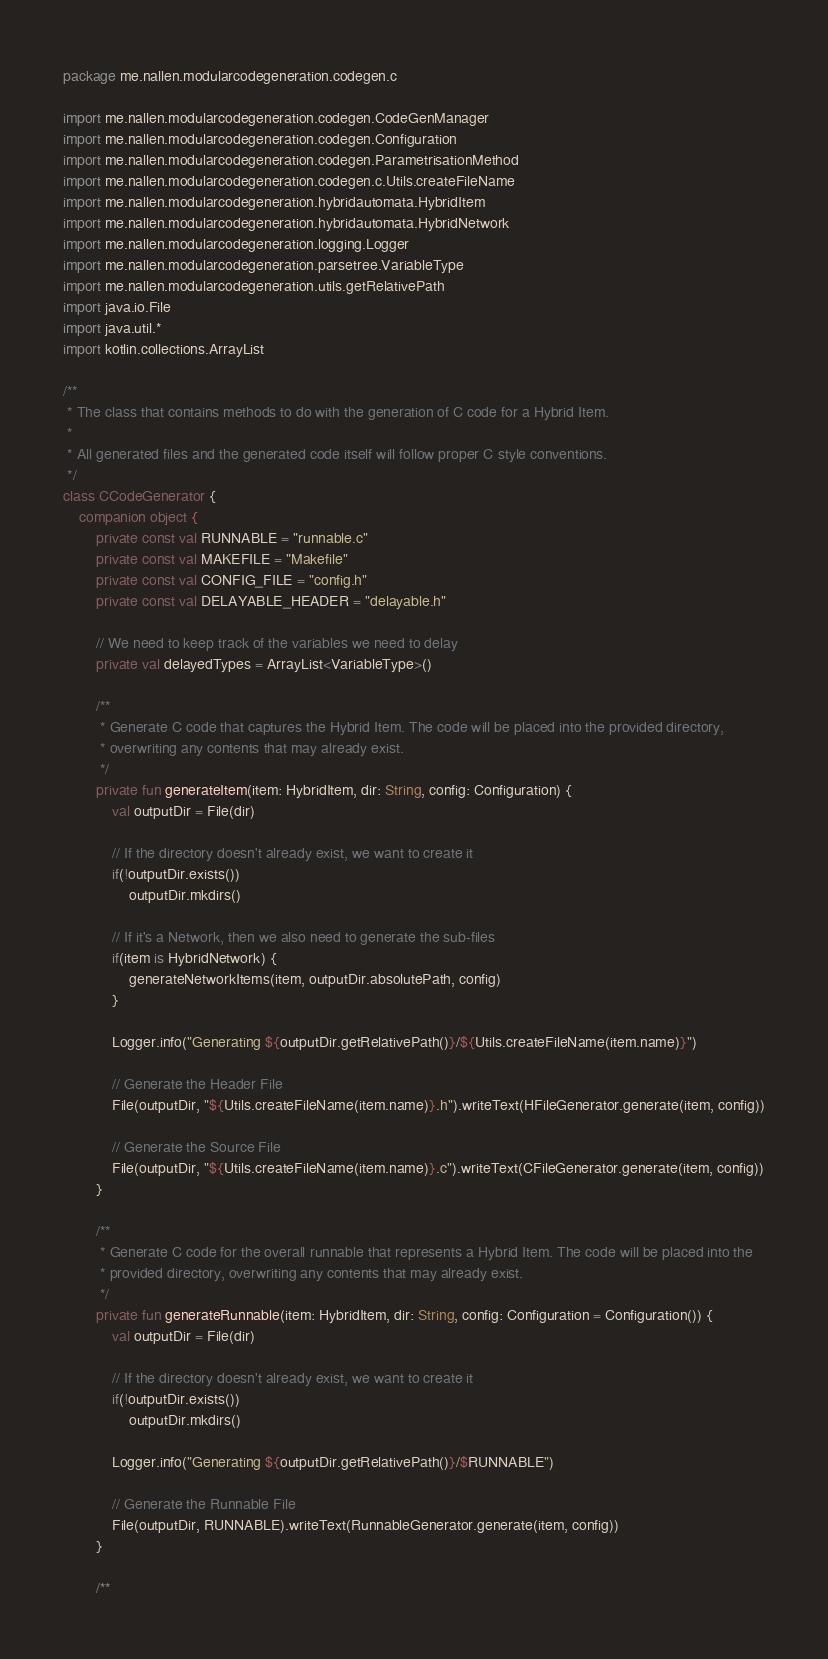Convert code to text. <code><loc_0><loc_0><loc_500><loc_500><_Kotlin_>package me.nallen.modularcodegeneration.codegen.c

import me.nallen.modularcodegeneration.codegen.CodeGenManager
import me.nallen.modularcodegeneration.codegen.Configuration
import me.nallen.modularcodegeneration.codegen.ParametrisationMethod
import me.nallen.modularcodegeneration.codegen.c.Utils.createFileName
import me.nallen.modularcodegeneration.hybridautomata.HybridItem
import me.nallen.modularcodegeneration.hybridautomata.HybridNetwork
import me.nallen.modularcodegeneration.logging.Logger
import me.nallen.modularcodegeneration.parsetree.VariableType
import me.nallen.modularcodegeneration.utils.getRelativePath
import java.io.File
import java.util.*
import kotlin.collections.ArrayList

/**
 * The class that contains methods to do with the generation of C code for a Hybrid Item.
 *
 * All generated files and the generated code itself will follow proper C style conventions.
 */
class CCodeGenerator {
    companion object {
        private const val RUNNABLE = "runnable.c"
        private const val MAKEFILE = "Makefile"
        private const val CONFIG_FILE = "config.h"
        private const val DELAYABLE_HEADER = "delayable.h"

        // We need to keep track of the variables we need to delay
        private val delayedTypes = ArrayList<VariableType>()

        /**
         * Generate C code that captures the Hybrid Item. The code will be placed into the provided directory,
         * overwriting any contents that may already exist.
         */
        private fun generateItem(item: HybridItem, dir: String, config: Configuration) {
            val outputDir = File(dir)

            // If the directory doesn't already exist, we want to create it
            if(!outputDir.exists())
                outputDir.mkdirs()

            // If it's a Network, then we also need to generate the sub-files
            if(item is HybridNetwork) {
                generateNetworkItems(item, outputDir.absolutePath, config)
            }

            Logger.info("Generating ${outputDir.getRelativePath()}/${Utils.createFileName(item.name)}")

            // Generate the Header File
            File(outputDir, "${Utils.createFileName(item.name)}.h").writeText(HFileGenerator.generate(item, config))

            // Generate the Source File
            File(outputDir, "${Utils.createFileName(item.name)}.c").writeText(CFileGenerator.generate(item, config))
        }

        /**
         * Generate C code for the overall runnable that represents a Hybrid Item. The code will be placed into the
         * provided directory, overwriting any contents that may already exist.
         */
        private fun generateRunnable(item: HybridItem, dir: String, config: Configuration = Configuration()) {
            val outputDir = File(dir)

            // If the directory doesn't already exist, we want to create it
            if(!outputDir.exists())
                outputDir.mkdirs()

            Logger.info("Generating ${outputDir.getRelativePath()}/$RUNNABLE")

            // Generate the Runnable File
            File(outputDir, RUNNABLE).writeText(RunnableGenerator.generate(item, config))
        }

        /**</code> 